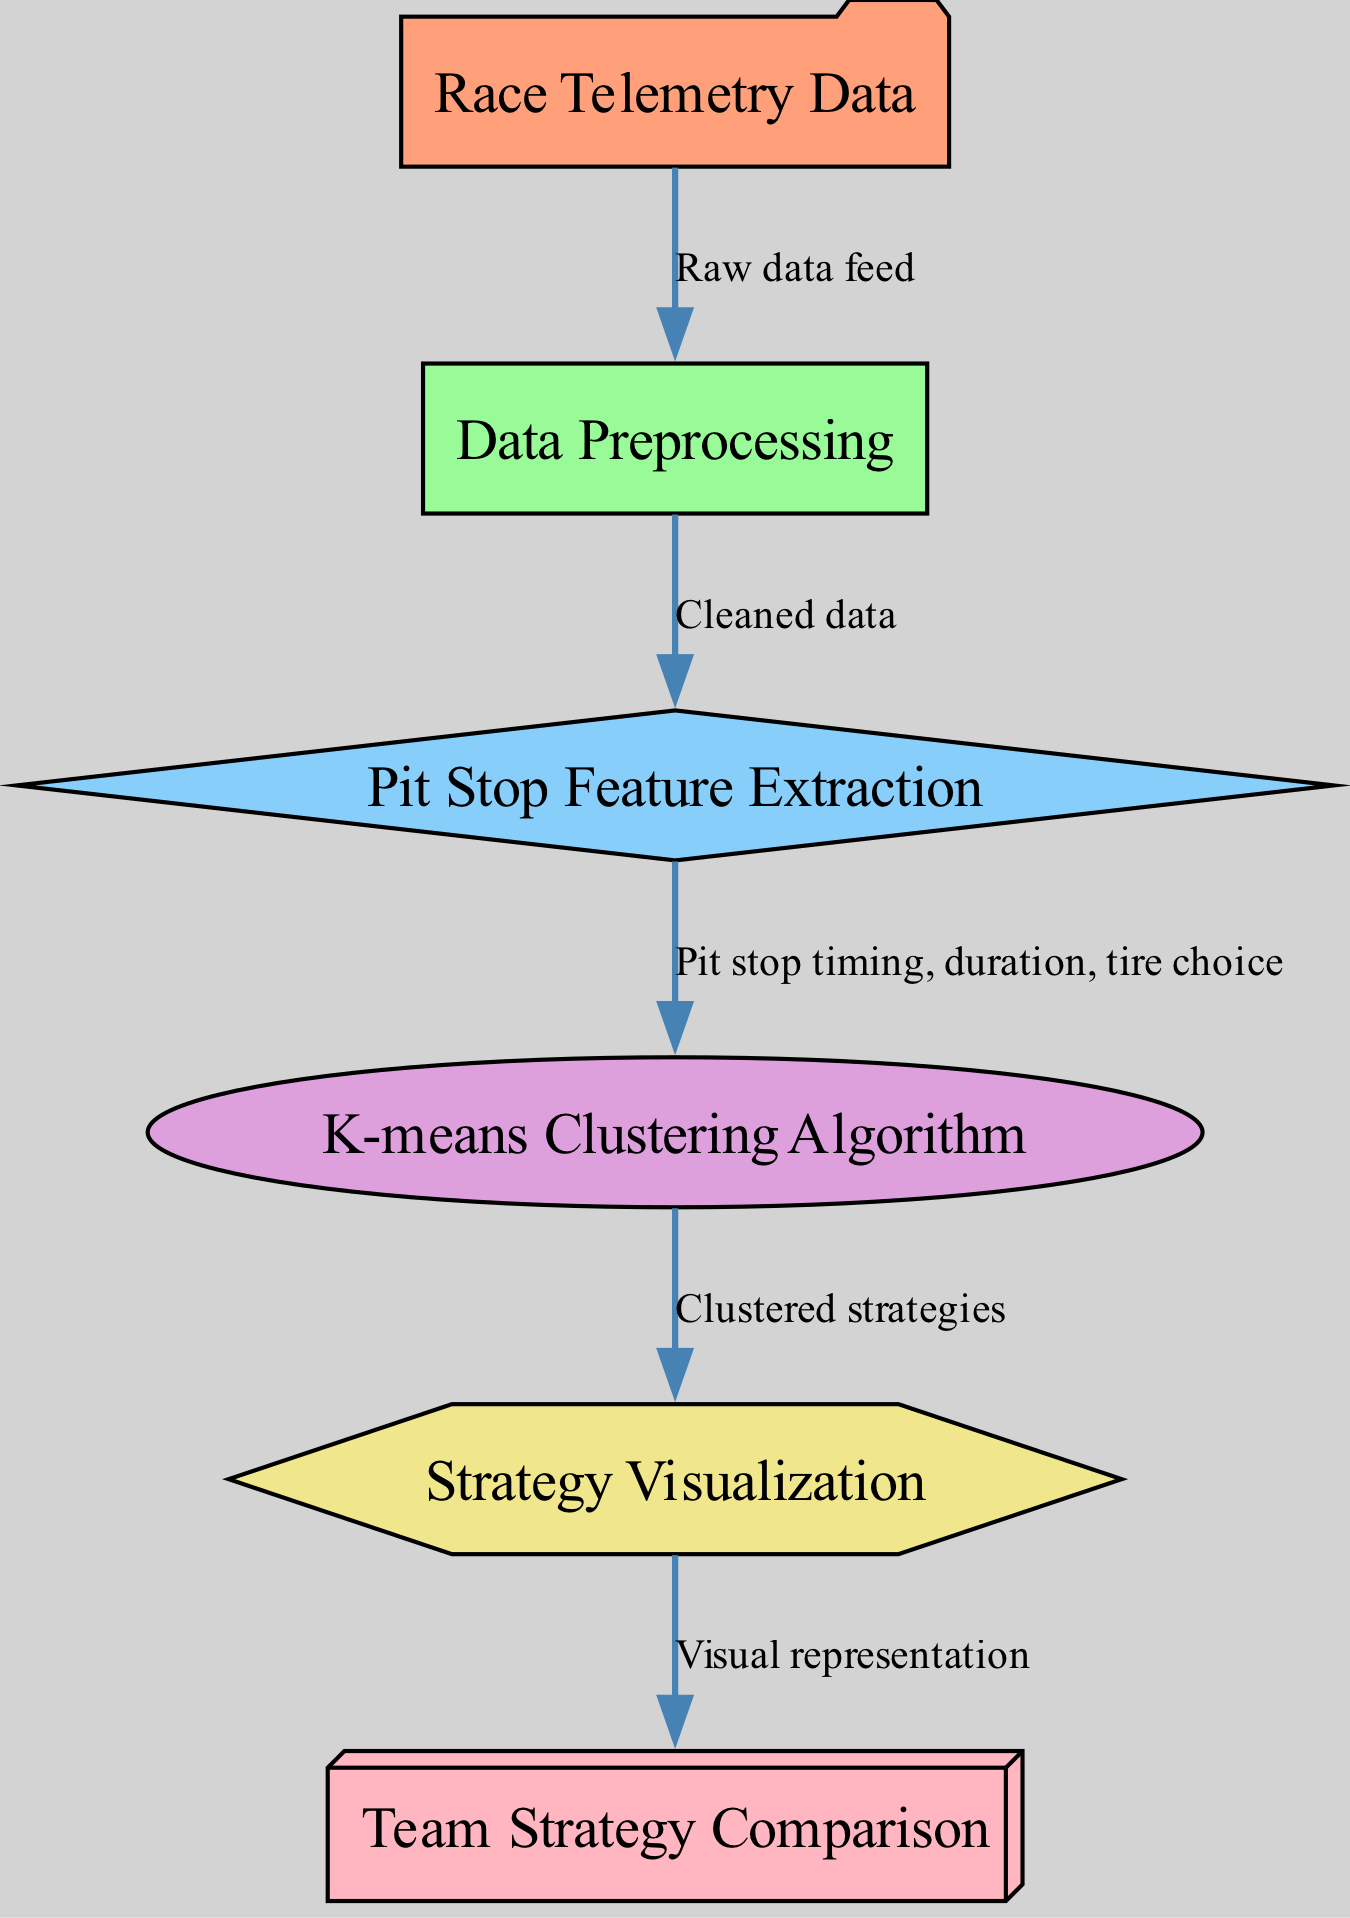What is the first node in the diagram? The first node in the diagram is labeled "Race Telemetry Data," which serves as the input for the entire process.
Answer: Race Telemetry Data How many edges are present in the diagram? There are five edges that connect the nodes, representing the flow of data from one process to another.
Answer: 5 What is the output node of the diagram? The output node of the diagram is labeled "Team Strategy Comparison," indicating the final result of the analyses performed.
Answer: Team Strategy Comparison Which node processes the data after preprocessing? The node that follows "Data Preprocessing" is "Pit Stop Feature Extraction," where specific features related to pit stops are extracted from the cleaned data.
Answer: Pit Stop Feature Extraction What type of algorithm is used in this diagram? The diagram specifically employs the "K-means Clustering Algorithm," which is a method for grouping data based on similarities.
Answer: K-means Clustering Algorithm How does the visualization relate to the output? The "Strategy Visualization" node takes the "Clustered strategies" from the clustering process and produces a "Visual representation" that serves as the output for comparison.
Answer: Visual representation What type of data is processed in the feature extraction node? The feature extraction node deals with data regarding "Pit stop timing, duration, tire choice," which are critical metrics for analyzing race strategies.
Answer: Pit stop timing, duration, tire choice Which node provides cleaned data for feature extraction? The "Data Preprocessing" node outputs "Cleaned data," ensuring that the subsequent analysis is performed on high-quality, refined data.
Answer: Cleaned data What shape represents the clustering node in the diagram? The shape of the clustering node in the diagram is represented as an "oval," which visually distinguishes it from other nodes.
Answer: Oval 